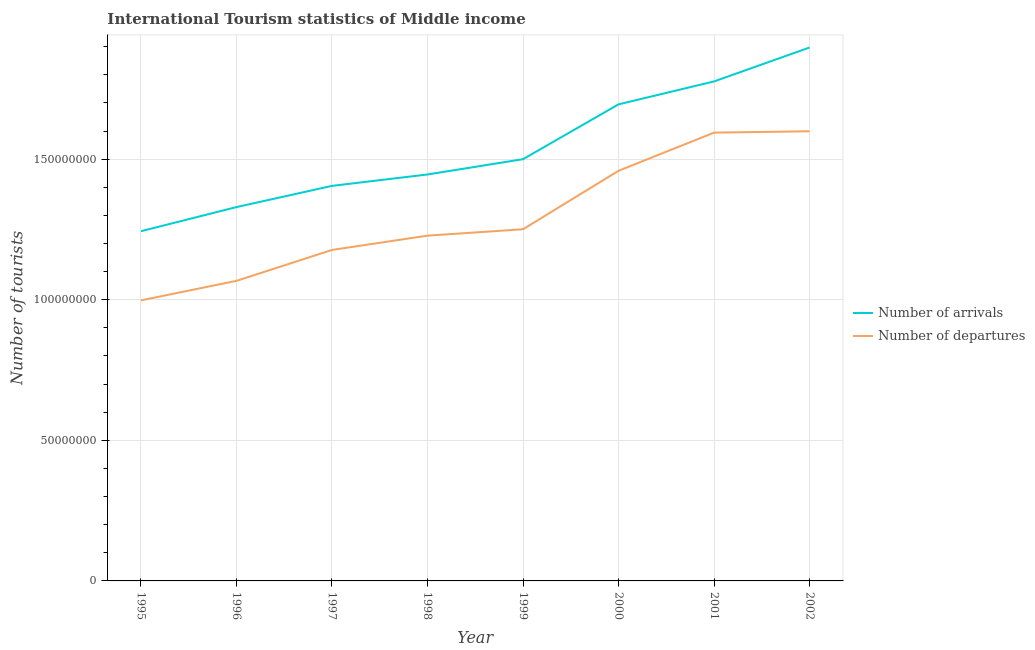Does the line corresponding to number of tourist departures intersect with the line corresponding to number of tourist arrivals?
Give a very brief answer. No. What is the number of tourist departures in 2001?
Keep it short and to the point. 1.59e+08. Across all years, what is the maximum number of tourist arrivals?
Provide a short and direct response. 1.90e+08. Across all years, what is the minimum number of tourist departures?
Offer a very short reply. 9.98e+07. What is the total number of tourist arrivals in the graph?
Provide a short and direct response. 1.23e+09. What is the difference between the number of tourist departures in 1996 and that in 1997?
Give a very brief answer. -1.10e+07. What is the difference between the number of tourist departures in 1996 and the number of tourist arrivals in 1995?
Offer a very short reply. -1.76e+07. What is the average number of tourist arrivals per year?
Give a very brief answer. 1.54e+08. In the year 2002, what is the difference between the number of tourist arrivals and number of tourist departures?
Provide a short and direct response. 2.98e+07. What is the ratio of the number of tourist arrivals in 1995 to that in 1997?
Provide a short and direct response. 0.89. Is the number of tourist departures in 1999 less than that in 2000?
Provide a short and direct response. Yes. Is the difference between the number of tourist arrivals in 2001 and 2002 greater than the difference between the number of tourist departures in 2001 and 2002?
Make the answer very short. No. What is the difference between the highest and the second highest number of tourist departures?
Keep it short and to the point. 4.80e+05. What is the difference between the highest and the lowest number of tourist arrivals?
Offer a terse response. 6.53e+07. In how many years, is the number of tourist arrivals greater than the average number of tourist arrivals taken over all years?
Keep it short and to the point. 3. Is the sum of the number of tourist arrivals in 1995 and 1999 greater than the maximum number of tourist departures across all years?
Make the answer very short. Yes. Is the number of tourist arrivals strictly less than the number of tourist departures over the years?
Offer a very short reply. No. How many years are there in the graph?
Ensure brevity in your answer.  8. Are the values on the major ticks of Y-axis written in scientific E-notation?
Offer a terse response. No. Does the graph contain any zero values?
Your answer should be compact. No. How many legend labels are there?
Offer a very short reply. 2. How are the legend labels stacked?
Give a very brief answer. Vertical. What is the title of the graph?
Keep it short and to the point. International Tourism statistics of Middle income. What is the label or title of the Y-axis?
Make the answer very short. Number of tourists. What is the Number of tourists of Number of arrivals in 1995?
Provide a short and direct response. 1.24e+08. What is the Number of tourists in Number of departures in 1995?
Provide a succinct answer. 9.98e+07. What is the Number of tourists in Number of arrivals in 1996?
Provide a succinct answer. 1.33e+08. What is the Number of tourists of Number of departures in 1996?
Provide a succinct answer. 1.07e+08. What is the Number of tourists of Number of arrivals in 1997?
Make the answer very short. 1.40e+08. What is the Number of tourists of Number of departures in 1997?
Make the answer very short. 1.18e+08. What is the Number of tourists of Number of arrivals in 1998?
Ensure brevity in your answer.  1.45e+08. What is the Number of tourists in Number of departures in 1998?
Give a very brief answer. 1.23e+08. What is the Number of tourists of Number of arrivals in 1999?
Give a very brief answer. 1.50e+08. What is the Number of tourists of Number of departures in 1999?
Your response must be concise. 1.25e+08. What is the Number of tourists of Number of arrivals in 2000?
Give a very brief answer. 1.69e+08. What is the Number of tourists in Number of departures in 2000?
Offer a terse response. 1.46e+08. What is the Number of tourists in Number of arrivals in 2001?
Your response must be concise. 1.78e+08. What is the Number of tourists in Number of departures in 2001?
Make the answer very short. 1.59e+08. What is the Number of tourists of Number of arrivals in 2002?
Your answer should be compact. 1.90e+08. What is the Number of tourists of Number of departures in 2002?
Give a very brief answer. 1.60e+08. Across all years, what is the maximum Number of tourists of Number of arrivals?
Make the answer very short. 1.90e+08. Across all years, what is the maximum Number of tourists of Number of departures?
Ensure brevity in your answer.  1.60e+08. Across all years, what is the minimum Number of tourists in Number of arrivals?
Provide a short and direct response. 1.24e+08. Across all years, what is the minimum Number of tourists in Number of departures?
Your answer should be compact. 9.98e+07. What is the total Number of tourists of Number of arrivals in the graph?
Your answer should be very brief. 1.23e+09. What is the total Number of tourists of Number of departures in the graph?
Your response must be concise. 1.04e+09. What is the difference between the Number of tourists of Number of arrivals in 1995 and that in 1996?
Ensure brevity in your answer.  -8.58e+06. What is the difference between the Number of tourists of Number of departures in 1995 and that in 1996?
Your response must be concise. -6.94e+06. What is the difference between the Number of tourists of Number of arrivals in 1995 and that in 1997?
Offer a terse response. -1.61e+07. What is the difference between the Number of tourists of Number of departures in 1995 and that in 1997?
Offer a terse response. -1.79e+07. What is the difference between the Number of tourists in Number of arrivals in 1995 and that in 1998?
Offer a very short reply. -2.02e+07. What is the difference between the Number of tourists of Number of departures in 1995 and that in 1998?
Your response must be concise. -2.30e+07. What is the difference between the Number of tourists in Number of arrivals in 1995 and that in 1999?
Provide a short and direct response. -2.56e+07. What is the difference between the Number of tourists in Number of departures in 1995 and that in 1999?
Give a very brief answer. -2.53e+07. What is the difference between the Number of tourists of Number of arrivals in 1995 and that in 2000?
Make the answer very short. -4.51e+07. What is the difference between the Number of tourists in Number of departures in 1995 and that in 2000?
Make the answer very short. -4.61e+07. What is the difference between the Number of tourists of Number of arrivals in 1995 and that in 2001?
Make the answer very short. -5.33e+07. What is the difference between the Number of tourists in Number of departures in 1995 and that in 2001?
Provide a short and direct response. -5.97e+07. What is the difference between the Number of tourists of Number of arrivals in 1995 and that in 2002?
Ensure brevity in your answer.  -6.53e+07. What is the difference between the Number of tourists of Number of departures in 1995 and that in 2002?
Your response must be concise. -6.01e+07. What is the difference between the Number of tourists of Number of arrivals in 1996 and that in 1997?
Make the answer very short. -7.54e+06. What is the difference between the Number of tourists in Number of departures in 1996 and that in 1997?
Give a very brief answer. -1.10e+07. What is the difference between the Number of tourists in Number of arrivals in 1996 and that in 1998?
Ensure brevity in your answer.  -1.16e+07. What is the difference between the Number of tourists of Number of departures in 1996 and that in 1998?
Make the answer very short. -1.61e+07. What is the difference between the Number of tourists of Number of arrivals in 1996 and that in 1999?
Give a very brief answer. -1.70e+07. What is the difference between the Number of tourists in Number of departures in 1996 and that in 1999?
Offer a very short reply. -1.84e+07. What is the difference between the Number of tourists in Number of arrivals in 1996 and that in 2000?
Keep it short and to the point. -3.65e+07. What is the difference between the Number of tourists in Number of departures in 1996 and that in 2000?
Your answer should be compact. -3.91e+07. What is the difference between the Number of tourists of Number of arrivals in 1996 and that in 2001?
Your response must be concise. -4.47e+07. What is the difference between the Number of tourists of Number of departures in 1996 and that in 2001?
Your answer should be very brief. -5.27e+07. What is the difference between the Number of tourists of Number of arrivals in 1996 and that in 2002?
Give a very brief answer. -5.67e+07. What is the difference between the Number of tourists of Number of departures in 1996 and that in 2002?
Your response must be concise. -5.32e+07. What is the difference between the Number of tourists of Number of arrivals in 1997 and that in 1998?
Your response must be concise. -4.06e+06. What is the difference between the Number of tourists in Number of departures in 1997 and that in 1998?
Your answer should be very brief. -5.08e+06. What is the difference between the Number of tourists in Number of arrivals in 1997 and that in 1999?
Your response must be concise. -9.49e+06. What is the difference between the Number of tourists of Number of departures in 1997 and that in 1999?
Ensure brevity in your answer.  -7.36e+06. What is the difference between the Number of tourists of Number of arrivals in 1997 and that in 2000?
Make the answer very short. -2.90e+07. What is the difference between the Number of tourists of Number of departures in 1997 and that in 2000?
Give a very brief answer. -2.81e+07. What is the difference between the Number of tourists of Number of arrivals in 1997 and that in 2001?
Offer a very short reply. -3.71e+07. What is the difference between the Number of tourists in Number of departures in 1997 and that in 2001?
Your answer should be compact. -4.17e+07. What is the difference between the Number of tourists of Number of arrivals in 1997 and that in 2002?
Ensure brevity in your answer.  -4.92e+07. What is the difference between the Number of tourists of Number of departures in 1997 and that in 2002?
Your response must be concise. -4.22e+07. What is the difference between the Number of tourists of Number of arrivals in 1998 and that in 1999?
Your answer should be very brief. -5.44e+06. What is the difference between the Number of tourists in Number of departures in 1998 and that in 1999?
Your response must be concise. -2.28e+06. What is the difference between the Number of tourists in Number of arrivals in 1998 and that in 2000?
Provide a succinct answer. -2.49e+07. What is the difference between the Number of tourists of Number of departures in 1998 and that in 2000?
Offer a very short reply. -2.31e+07. What is the difference between the Number of tourists in Number of arrivals in 1998 and that in 2001?
Offer a terse response. -3.31e+07. What is the difference between the Number of tourists of Number of departures in 1998 and that in 2001?
Provide a short and direct response. -3.66e+07. What is the difference between the Number of tourists of Number of arrivals in 1998 and that in 2002?
Make the answer very short. -4.51e+07. What is the difference between the Number of tourists of Number of departures in 1998 and that in 2002?
Provide a succinct answer. -3.71e+07. What is the difference between the Number of tourists in Number of arrivals in 1999 and that in 2000?
Provide a short and direct response. -1.95e+07. What is the difference between the Number of tourists in Number of departures in 1999 and that in 2000?
Offer a terse response. -2.08e+07. What is the difference between the Number of tourists in Number of arrivals in 1999 and that in 2001?
Offer a very short reply. -2.77e+07. What is the difference between the Number of tourists in Number of departures in 1999 and that in 2001?
Offer a very short reply. -3.44e+07. What is the difference between the Number of tourists of Number of arrivals in 1999 and that in 2002?
Offer a terse response. -3.97e+07. What is the difference between the Number of tourists of Number of departures in 1999 and that in 2002?
Ensure brevity in your answer.  -3.48e+07. What is the difference between the Number of tourists of Number of arrivals in 2000 and that in 2001?
Ensure brevity in your answer.  -8.16e+06. What is the difference between the Number of tourists in Number of departures in 2000 and that in 2001?
Make the answer very short. -1.36e+07. What is the difference between the Number of tourists in Number of arrivals in 2000 and that in 2002?
Offer a terse response. -2.02e+07. What is the difference between the Number of tourists in Number of departures in 2000 and that in 2002?
Ensure brevity in your answer.  -1.41e+07. What is the difference between the Number of tourists of Number of arrivals in 2001 and that in 2002?
Provide a succinct answer. -1.21e+07. What is the difference between the Number of tourists in Number of departures in 2001 and that in 2002?
Your response must be concise. -4.80e+05. What is the difference between the Number of tourists of Number of arrivals in 1995 and the Number of tourists of Number of departures in 1996?
Your response must be concise. 1.76e+07. What is the difference between the Number of tourists in Number of arrivals in 1995 and the Number of tourists in Number of departures in 1997?
Make the answer very short. 6.65e+06. What is the difference between the Number of tourists in Number of arrivals in 1995 and the Number of tourists in Number of departures in 1998?
Your answer should be compact. 1.57e+06. What is the difference between the Number of tourists of Number of arrivals in 1995 and the Number of tourists of Number of departures in 1999?
Ensure brevity in your answer.  -7.04e+05. What is the difference between the Number of tourists of Number of arrivals in 1995 and the Number of tourists of Number of departures in 2000?
Your response must be concise. -2.15e+07. What is the difference between the Number of tourists in Number of arrivals in 1995 and the Number of tourists in Number of departures in 2001?
Offer a very short reply. -3.51e+07. What is the difference between the Number of tourists in Number of arrivals in 1995 and the Number of tourists in Number of departures in 2002?
Make the answer very short. -3.56e+07. What is the difference between the Number of tourists in Number of arrivals in 1996 and the Number of tourists in Number of departures in 1997?
Your answer should be compact. 1.52e+07. What is the difference between the Number of tourists of Number of arrivals in 1996 and the Number of tourists of Number of departures in 1998?
Your response must be concise. 1.02e+07. What is the difference between the Number of tourists of Number of arrivals in 1996 and the Number of tourists of Number of departures in 1999?
Provide a succinct answer. 7.88e+06. What is the difference between the Number of tourists in Number of arrivals in 1996 and the Number of tourists in Number of departures in 2000?
Your response must be concise. -1.29e+07. What is the difference between the Number of tourists of Number of arrivals in 1996 and the Number of tourists of Number of departures in 2001?
Provide a short and direct response. -2.65e+07. What is the difference between the Number of tourists of Number of arrivals in 1996 and the Number of tourists of Number of departures in 2002?
Your answer should be compact. -2.70e+07. What is the difference between the Number of tourists in Number of arrivals in 1997 and the Number of tourists in Number of departures in 1998?
Ensure brevity in your answer.  1.77e+07. What is the difference between the Number of tourists of Number of arrivals in 1997 and the Number of tourists of Number of departures in 1999?
Your answer should be very brief. 1.54e+07. What is the difference between the Number of tourists in Number of arrivals in 1997 and the Number of tourists in Number of departures in 2000?
Offer a terse response. -5.36e+06. What is the difference between the Number of tourists of Number of arrivals in 1997 and the Number of tourists of Number of departures in 2001?
Keep it short and to the point. -1.89e+07. What is the difference between the Number of tourists in Number of arrivals in 1997 and the Number of tourists in Number of departures in 2002?
Your response must be concise. -1.94e+07. What is the difference between the Number of tourists of Number of arrivals in 1998 and the Number of tourists of Number of departures in 1999?
Provide a succinct answer. 1.95e+07. What is the difference between the Number of tourists in Number of arrivals in 1998 and the Number of tourists in Number of departures in 2000?
Offer a terse response. -1.31e+06. What is the difference between the Number of tourists of Number of arrivals in 1998 and the Number of tourists of Number of departures in 2001?
Your response must be concise. -1.49e+07. What is the difference between the Number of tourists of Number of arrivals in 1998 and the Number of tourists of Number of departures in 2002?
Your answer should be very brief. -1.54e+07. What is the difference between the Number of tourists of Number of arrivals in 1999 and the Number of tourists of Number of departures in 2000?
Give a very brief answer. 4.13e+06. What is the difference between the Number of tourists of Number of arrivals in 1999 and the Number of tourists of Number of departures in 2001?
Your answer should be very brief. -9.45e+06. What is the difference between the Number of tourists in Number of arrivals in 1999 and the Number of tourists in Number of departures in 2002?
Provide a succinct answer. -9.93e+06. What is the difference between the Number of tourists of Number of arrivals in 2000 and the Number of tourists of Number of departures in 2001?
Make the answer very short. 1.00e+07. What is the difference between the Number of tourists of Number of arrivals in 2000 and the Number of tourists of Number of departures in 2002?
Ensure brevity in your answer.  9.57e+06. What is the difference between the Number of tourists in Number of arrivals in 2001 and the Number of tourists in Number of departures in 2002?
Make the answer very short. 1.77e+07. What is the average Number of tourists of Number of arrivals per year?
Offer a very short reply. 1.54e+08. What is the average Number of tourists of Number of departures per year?
Keep it short and to the point. 1.30e+08. In the year 1995, what is the difference between the Number of tourists in Number of arrivals and Number of tourists in Number of departures?
Offer a very short reply. 2.46e+07. In the year 1996, what is the difference between the Number of tourists of Number of arrivals and Number of tourists of Number of departures?
Keep it short and to the point. 2.62e+07. In the year 1997, what is the difference between the Number of tourists in Number of arrivals and Number of tourists in Number of departures?
Your answer should be compact. 2.28e+07. In the year 1998, what is the difference between the Number of tourists in Number of arrivals and Number of tourists in Number of departures?
Your response must be concise. 2.18e+07. In the year 1999, what is the difference between the Number of tourists in Number of arrivals and Number of tourists in Number of departures?
Keep it short and to the point. 2.49e+07. In the year 2000, what is the difference between the Number of tourists of Number of arrivals and Number of tourists of Number of departures?
Ensure brevity in your answer.  2.36e+07. In the year 2001, what is the difference between the Number of tourists of Number of arrivals and Number of tourists of Number of departures?
Provide a succinct answer. 1.82e+07. In the year 2002, what is the difference between the Number of tourists of Number of arrivals and Number of tourists of Number of departures?
Give a very brief answer. 2.98e+07. What is the ratio of the Number of tourists in Number of arrivals in 1995 to that in 1996?
Offer a terse response. 0.94. What is the ratio of the Number of tourists of Number of departures in 1995 to that in 1996?
Provide a succinct answer. 0.93. What is the ratio of the Number of tourists in Number of arrivals in 1995 to that in 1997?
Make the answer very short. 0.89. What is the ratio of the Number of tourists of Number of departures in 1995 to that in 1997?
Your answer should be compact. 0.85. What is the ratio of the Number of tourists in Number of arrivals in 1995 to that in 1998?
Make the answer very short. 0.86. What is the ratio of the Number of tourists in Number of departures in 1995 to that in 1998?
Offer a terse response. 0.81. What is the ratio of the Number of tourists of Number of arrivals in 1995 to that in 1999?
Your answer should be very brief. 0.83. What is the ratio of the Number of tourists in Number of departures in 1995 to that in 1999?
Make the answer very short. 0.8. What is the ratio of the Number of tourists of Number of arrivals in 1995 to that in 2000?
Keep it short and to the point. 0.73. What is the ratio of the Number of tourists in Number of departures in 1995 to that in 2000?
Make the answer very short. 0.68. What is the ratio of the Number of tourists in Number of arrivals in 1995 to that in 2001?
Make the answer very short. 0.7. What is the ratio of the Number of tourists of Number of departures in 1995 to that in 2001?
Provide a succinct answer. 0.63. What is the ratio of the Number of tourists in Number of arrivals in 1995 to that in 2002?
Give a very brief answer. 0.66. What is the ratio of the Number of tourists in Number of departures in 1995 to that in 2002?
Ensure brevity in your answer.  0.62. What is the ratio of the Number of tourists of Number of arrivals in 1996 to that in 1997?
Keep it short and to the point. 0.95. What is the ratio of the Number of tourists of Number of departures in 1996 to that in 1997?
Give a very brief answer. 0.91. What is the ratio of the Number of tourists in Number of arrivals in 1996 to that in 1998?
Provide a succinct answer. 0.92. What is the ratio of the Number of tourists of Number of departures in 1996 to that in 1998?
Your response must be concise. 0.87. What is the ratio of the Number of tourists in Number of arrivals in 1996 to that in 1999?
Your response must be concise. 0.89. What is the ratio of the Number of tourists of Number of departures in 1996 to that in 1999?
Offer a terse response. 0.85. What is the ratio of the Number of tourists of Number of arrivals in 1996 to that in 2000?
Provide a short and direct response. 0.78. What is the ratio of the Number of tourists in Number of departures in 1996 to that in 2000?
Offer a terse response. 0.73. What is the ratio of the Number of tourists in Number of arrivals in 1996 to that in 2001?
Make the answer very short. 0.75. What is the ratio of the Number of tourists of Number of departures in 1996 to that in 2001?
Provide a succinct answer. 0.67. What is the ratio of the Number of tourists in Number of arrivals in 1996 to that in 2002?
Provide a succinct answer. 0.7. What is the ratio of the Number of tourists in Number of departures in 1996 to that in 2002?
Offer a very short reply. 0.67. What is the ratio of the Number of tourists in Number of arrivals in 1997 to that in 1998?
Provide a short and direct response. 0.97. What is the ratio of the Number of tourists in Number of departures in 1997 to that in 1998?
Provide a short and direct response. 0.96. What is the ratio of the Number of tourists in Number of arrivals in 1997 to that in 1999?
Your answer should be very brief. 0.94. What is the ratio of the Number of tourists of Number of departures in 1997 to that in 1999?
Your answer should be compact. 0.94. What is the ratio of the Number of tourists in Number of arrivals in 1997 to that in 2000?
Offer a terse response. 0.83. What is the ratio of the Number of tourists of Number of departures in 1997 to that in 2000?
Provide a short and direct response. 0.81. What is the ratio of the Number of tourists in Number of arrivals in 1997 to that in 2001?
Give a very brief answer. 0.79. What is the ratio of the Number of tourists in Number of departures in 1997 to that in 2001?
Make the answer very short. 0.74. What is the ratio of the Number of tourists of Number of arrivals in 1997 to that in 2002?
Ensure brevity in your answer.  0.74. What is the ratio of the Number of tourists in Number of departures in 1997 to that in 2002?
Your answer should be very brief. 0.74. What is the ratio of the Number of tourists of Number of arrivals in 1998 to that in 1999?
Provide a succinct answer. 0.96. What is the ratio of the Number of tourists of Number of departures in 1998 to that in 1999?
Offer a very short reply. 0.98. What is the ratio of the Number of tourists in Number of arrivals in 1998 to that in 2000?
Offer a very short reply. 0.85. What is the ratio of the Number of tourists in Number of departures in 1998 to that in 2000?
Your response must be concise. 0.84. What is the ratio of the Number of tourists of Number of arrivals in 1998 to that in 2001?
Your answer should be very brief. 0.81. What is the ratio of the Number of tourists of Number of departures in 1998 to that in 2001?
Offer a terse response. 0.77. What is the ratio of the Number of tourists in Number of arrivals in 1998 to that in 2002?
Keep it short and to the point. 0.76. What is the ratio of the Number of tourists of Number of departures in 1998 to that in 2002?
Keep it short and to the point. 0.77. What is the ratio of the Number of tourists in Number of arrivals in 1999 to that in 2000?
Ensure brevity in your answer.  0.89. What is the ratio of the Number of tourists of Number of departures in 1999 to that in 2000?
Make the answer very short. 0.86. What is the ratio of the Number of tourists of Number of arrivals in 1999 to that in 2001?
Offer a very short reply. 0.84. What is the ratio of the Number of tourists in Number of departures in 1999 to that in 2001?
Your answer should be very brief. 0.78. What is the ratio of the Number of tourists of Number of arrivals in 1999 to that in 2002?
Ensure brevity in your answer.  0.79. What is the ratio of the Number of tourists in Number of departures in 1999 to that in 2002?
Your answer should be very brief. 0.78. What is the ratio of the Number of tourists of Number of arrivals in 2000 to that in 2001?
Keep it short and to the point. 0.95. What is the ratio of the Number of tourists in Number of departures in 2000 to that in 2001?
Ensure brevity in your answer.  0.91. What is the ratio of the Number of tourists of Number of arrivals in 2000 to that in 2002?
Provide a succinct answer. 0.89. What is the ratio of the Number of tourists in Number of departures in 2000 to that in 2002?
Your response must be concise. 0.91. What is the ratio of the Number of tourists of Number of arrivals in 2001 to that in 2002?
Your response must be concise. 0.94. What is the difference between the highest and the second highest Number of tourists of Number of arrivals?
Your answer should be compact. 1.21e+07. What is the difference between the highest and the second highest Number of tourists of Number of departures?
Give a very brief answer. 4.80e+05. What is the difference between the highest and the lowest Number of tourists in Number of arrivals?
Ensure brevity in your answer.  6.53e+07. What is the difference between the highest and the lowest Number of tourists in Number of departures?
Your response must be concise. 6.01e+07. 